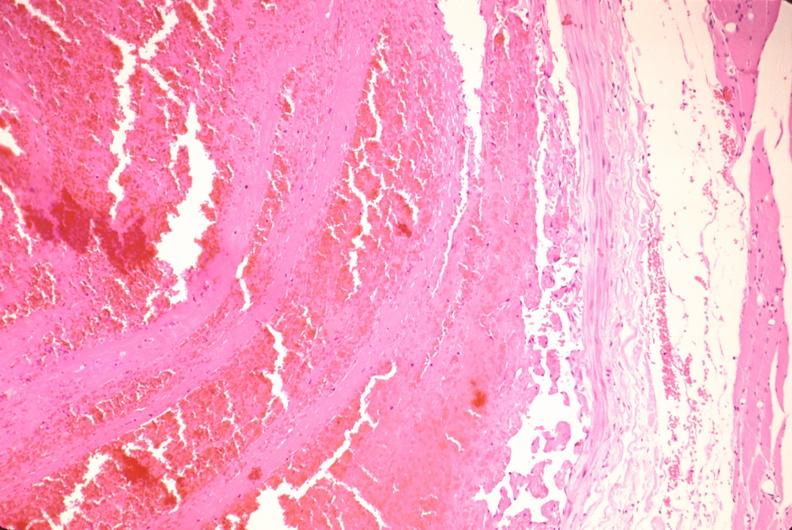s conjoined twins present?
Answer the question using a single word or phrase. No 